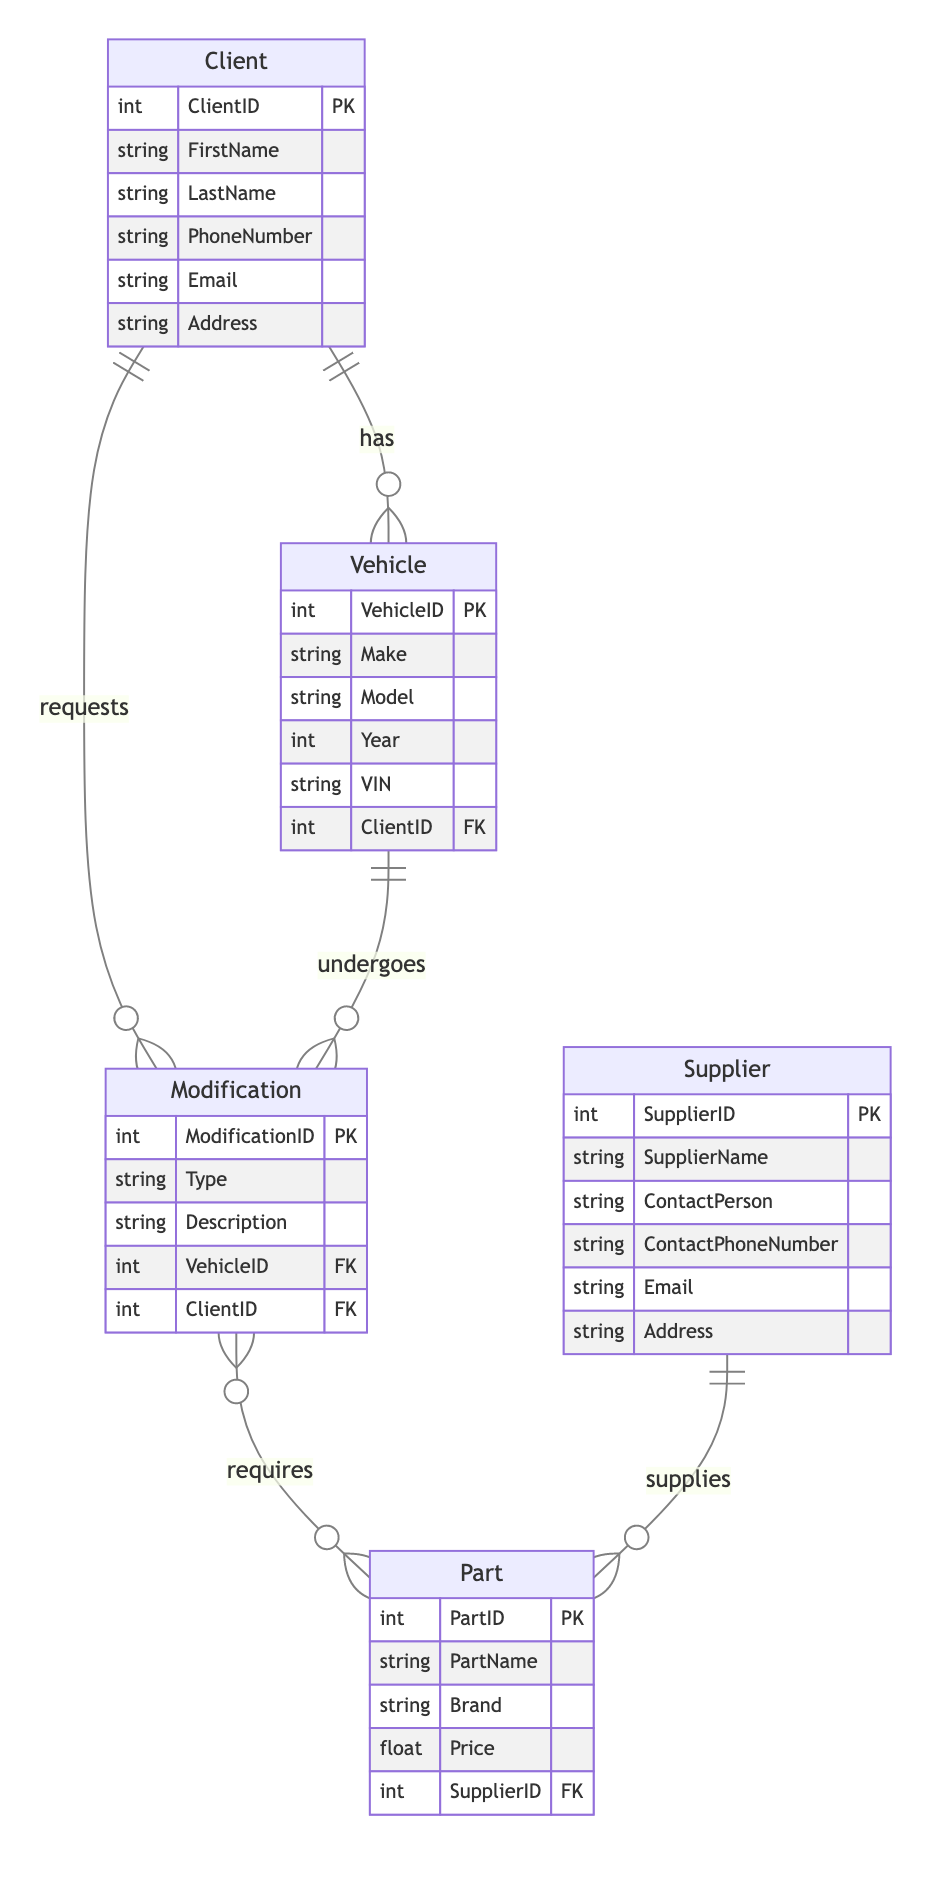What is the primary key of the Client entity? The primary key is a unique identifier for each Client. According to the diagram, the primary key for the Client entity is "ClientID".
Answer: ClientID How many attributes are there in the Vehicle entity? The Vehicle entity has a specific number of attributes listed in the diagram. Upon counting them, the attributes are: VehicleID, Make, Model, Year, VIN, and ClientID, totaling six attributes.
Answer: 6 What type of relationship exists between Modification and Part? The relationship between Modification and Part is defined as a many-to-many relationship in the diagram, indicated by the notation used.
Answer: ManyToMany Which entity is linked to the Supplier via the SupplierID? The Part entity is linked to the Supplier through the foreign key SupplierID, indicating that each part is supplied by a supplier.
Answer: Part How many modifications can a single client request? The relationship between Client and Modification is a one-to-many relationship. This means one client can request multiple modifications, but the exact number is not defined in the diagram.
Answer: Many What attribute of the Vehicle is used to link it to the Client? The linking attribute between the Vehicle and its associated Client is the foreign key ClientID, as per the diagram's notation.
Answer: ClientID How many entities are displaying what a supplier supplies? The diagram illustrates the Supplier and Part entities; since the Supplier supplies Parts, there are two entities involved in this aspect of the diagram. Therefore, this relationship spans these two entities.
Answer: 2 What is the description of the ClientVehicle relationship? The ClientVehicle relationship, as depicted in the diagram, describes how a client can own multiple vehicles, establishing a one-to-many relationship from Client to Vehicle.
Answer: OneToMany Who does the contact person belong to in the diagram? The contact person belongs to the Supplier entity, which is responsible for supplying parts. This can be understood by observing the attributes of the Supplier entity in the diagram.
Answer: Supplier 